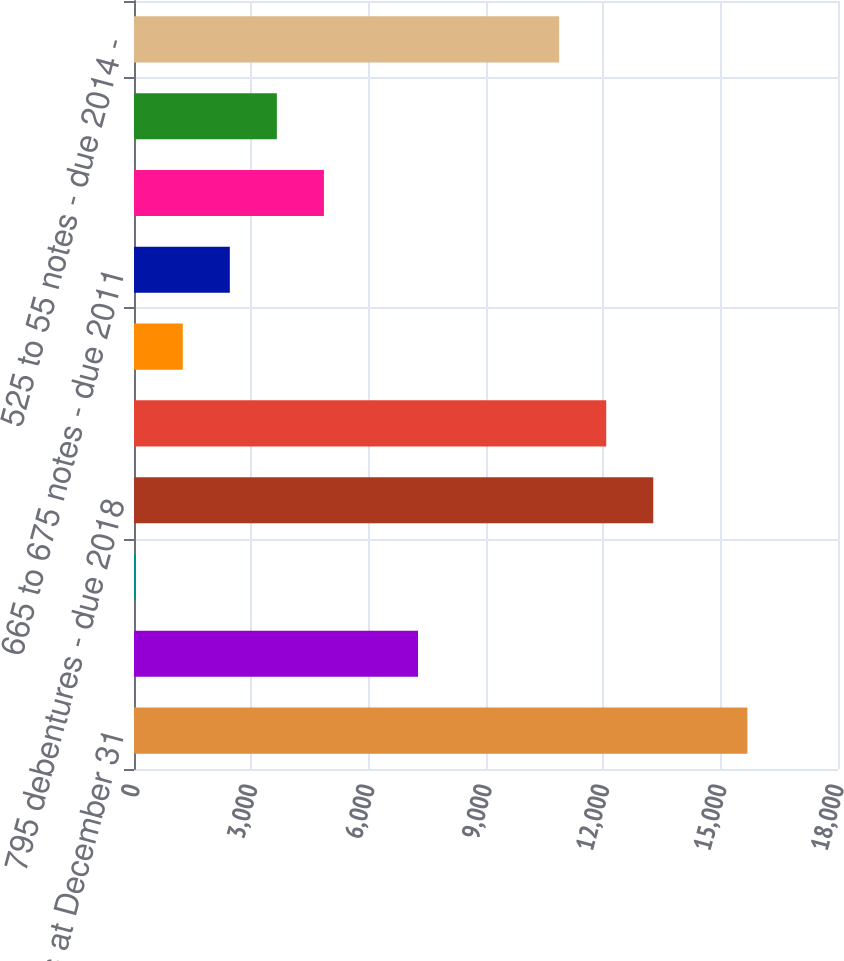<chart> <loc_0><loc_0><loc_500><loc_500><bar_chart><fcel>In millions at December 31<fcel>87 to 10 notes - due 2038<fcel>925 debentures - due 2011<fcel>795 debentures - due 2018<fcel>74 debentures - due 2014<fcel>6 7/8 notes - due 2023 - 2029<fcel>665 to 675 notes - due 2011<fcel>64 to 775 debentures due 2025<fcel>585 notes - due 2012<fcel>525 to 55 notes - due 2014 -<nl><fcel>15683<fcel>7262<fcel>44<fcel>13277<fcel>12074<fcel>1247<fcel>2450<fcel>4856<fcel>3653<fcel>10871<nl></chart> 